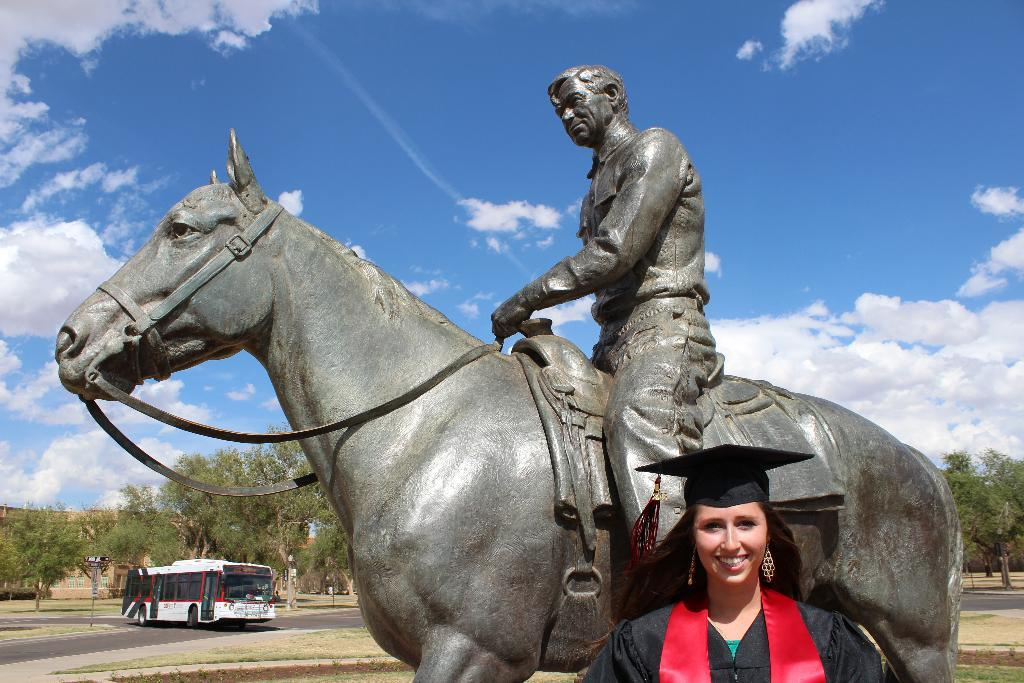Who is present in the image? There is a woman in the image. What can be seen in the background of the image? There is a bus and trees visible in the background of the image. What is the weather like in the image? The sky is full of clouds, suggesting a potentially overcast or cloudy day. What is the woman standing near in the image? The woman is standing near a statue of a man and horse. Are there any birds perched on the dock in the image? There is no dock present in the image, and therefore no birds can be seen perched on it. 